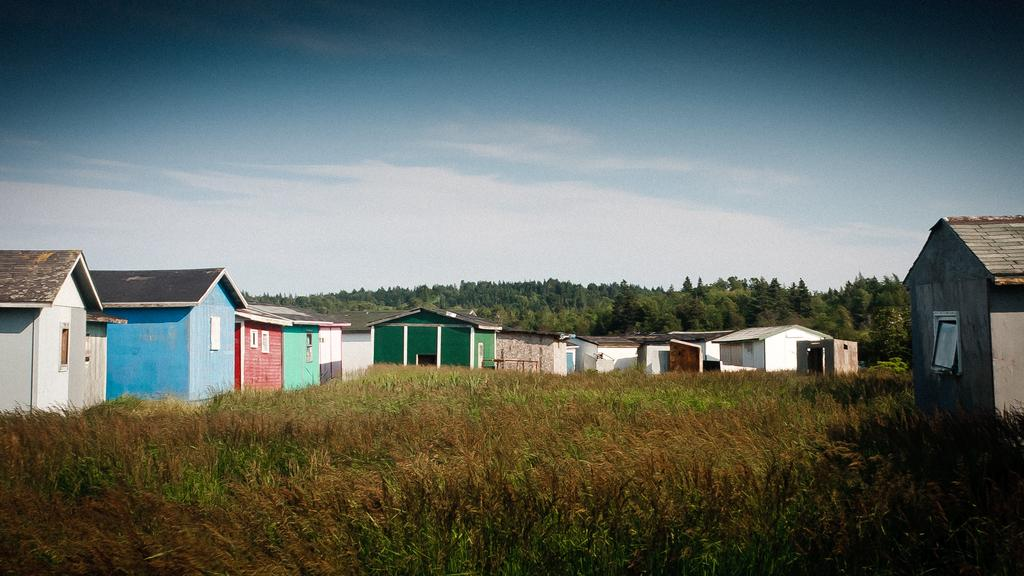What type of vegetation is present on the ground in the image? There are plants and grass on the ground in the image. What structures can be seen in the background? There are houses with roofs in the background. What type of natural elements are visible in the background? There are trees and clouds in the sky in the background. Where is the harbor located in the image? There is no harbor present in the image. What type of food is being cooked in the image? There is no cooking or food preparation visible in the image. 